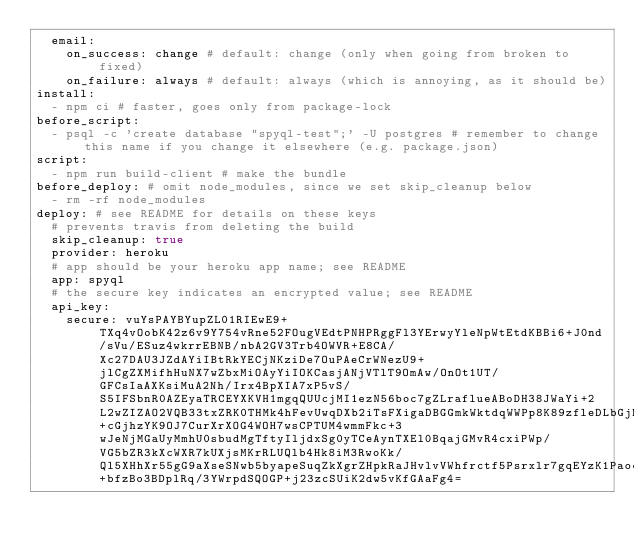<code> <loc_0><loc_0><loc_500><loc_500><_YAML_>  email:
    on_success: change # default: change (only when going from broken to fixed)
    on_failure: always # default: always (which is annoying, as it should be)
install:
  - npm ci # faster, goes only from package-lock
before_script:
  - psql -c 'create database "spyql-test";' -U postgres # remember to change this name if you change it elsewhere (e.g. package.json)
script:
  - npm run build-client # make the bundle
before_deploy: # omit node_modules, since we set skip_cleanup below
  - rm -rf node_modules
deploy: # see README for details on these keys
  # prevents travis from deleting the build
  skip_cleanup: true
  provider: heroku
  # app should be your heroku app name; see README
  app: spyql
  # the secure key indicates an encrypted value; see README
  api_key:
    secure: vuYsPAYBYupZL01RIEwE9+TXq4vOobK42z6v9Y754vRne52FOugVEdtPNHPRggFl3YErwyYleNpWtEtdKBBi6+J0nd/sVu/ESuz4wkrrEBNB/nbA2GV3Trb4OWVR+E8CA/Xc27DAU3JZdAYiIBtRkYECjNKziDe7OuPAeCrWNezU9+jlCgZXMifhHuNX7wZbxMiOAyYiIOKCasjANjVTlT9OmAw/OnOt1UT/GFCsIaAXKsiMuA2Nh/Irx4BpXIA7xP5vS/S5IFSbnR0AZEyaTRCEYXKVH1mgqQUUcjMI1ezN56boc7gZLraflueABoDH38JWaYi+2L2wZIZAO2VQB33txZRK0THMk4hFevUwqDXb2iTsFXigaDBGGmkWktdqWWPp8K89zfleDLbGjMtj2JEVWeLRelCxS6+cGjhzYK9OJ7CurXrXOG4WOH7wsCPTUM4wmmFkc+3wJeNjMGaUyMmhU0sbudMgTftyIljdxSg0yTCeAynTXEl0BqajGMvR4cxiPWp/VG5bZR3kXcWXR7kUXjsMKrRLUQlb4Hk8iM3RwoKk/Ql5XHhXr55gG9aXseSNwb5byapeSuqZkXgrZHpkRaJHvlvVWhfrctf5Psrxlr7gqEYzK1Paocf+bfzBo3BDplRq/3YWrpdSQOGP+j23zcSUiK2dw5vKfGAaFg4=
</code> 